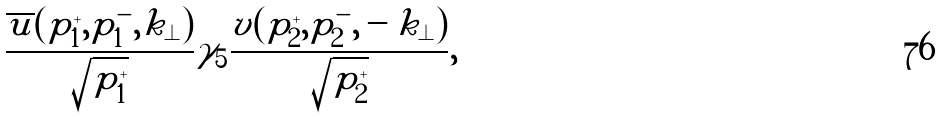Convert formula to latex. <formula><loc_0><loc_0><loc_500><loc_500>\frac { \overline { u } ( p _ { 1 } ^ { + } , p _ { 1 } ^ { - } , k _ { \perp } ) } { \sqrt { p _ { 1 } ^ { + } } } \gamma _ { 5 } \frac { v ( p _ { 2 } ^ { + } , p _ { 2 } ^ { - } , - k _ { \perp } ) } { \sqrt { p _ { 2 } ^ { + } } } ,</formula> 